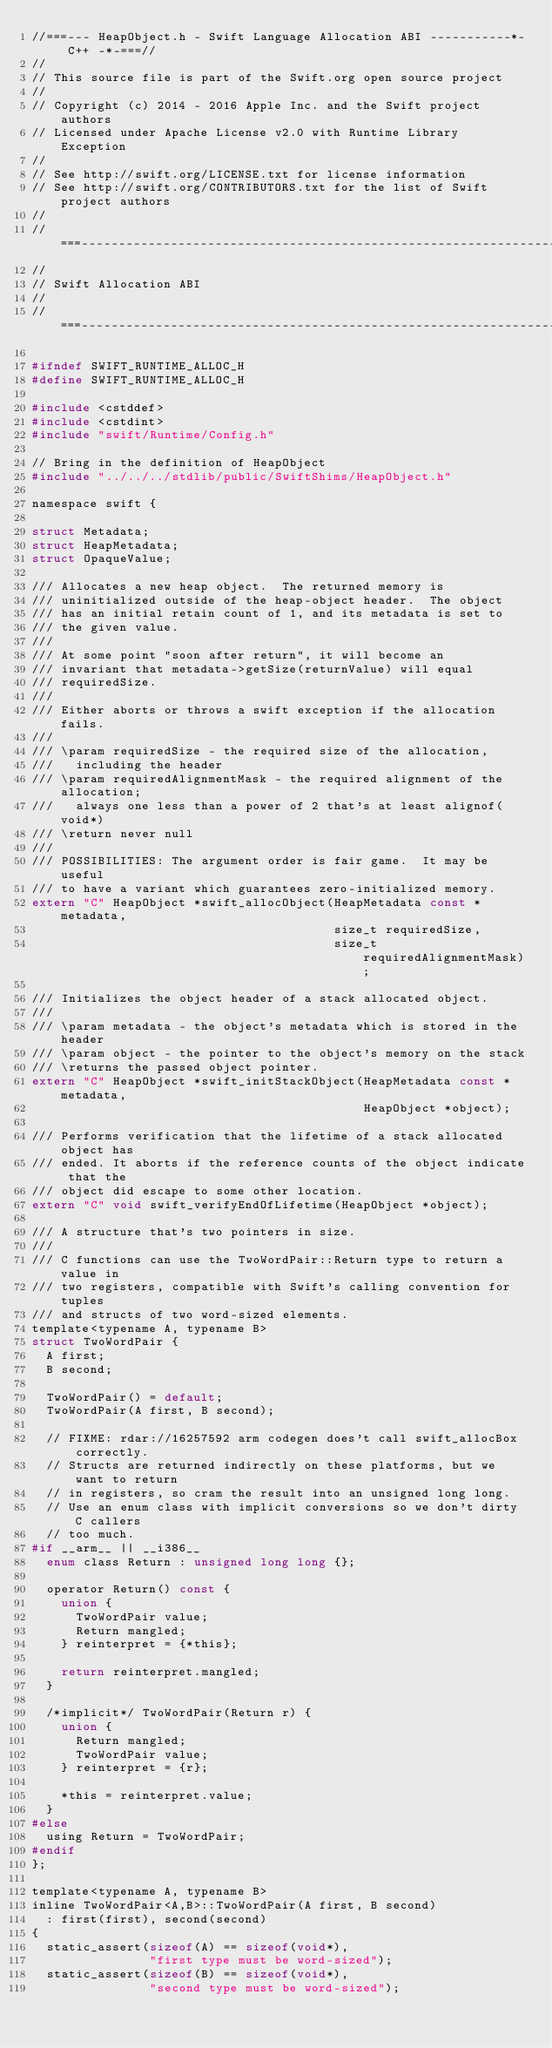<code> <loc_0><loc_0><loc_500><loc_500><_C_>//===--- HeapObject.h - Swift Language Allocation ABI -----------*- C++ -*-===//
//
// This source file is part of the Swift.org open source project
//
// Copyright (c) 2014 - 2016 Apple Inc. and the Swift project authors
// Licensed under Apache License v2.0 with Runtime Library Exception
//
// See http://swift.org/LICENSE.txt for license information
// See http://swift.org/CONTRIBUTORS.txt for the list of Swift project authors
//
//===----------------------------------------------------------------------===//
//
// Swift Allocation ABI
//
//===----------------------------------------------------------------------===//

#ifndef SWIFT_RUNTIME_ALLOC_H
#define SWIFT_RUNTIME_ALLOC_H

#include <cstddef>
#include <cstdint>
#include "swift/Runtime/Config.h"

// Bring in the definition of HeapObject 
#include "../../../stdlib/public/SwiftShims/HeapObject.h"

namespace swift {

struct Metadata;
struct HeapMetadata;
struct OpaqueValue;

/// Allocates a new heap object.  The returned memory is
/// uninitialized outside of the heap-object header.  The object
/// has an initial retain count of 1, and its metadata is set to
/// the given value.
///
/// At some point "soon after return", it will become an
/// invariant that metadata->getSize(returnValue) will equal
/// requiredSize.
///
/// Either aborts or throws a swift exception if the allocation fails.
///
/// \param requiredSize - the required size of the allocation,
///   including the header
/// \param requiredAlignmentMask - the required alignment of the allocation;
///   always one less than a power of 2 that's at least alignof(void*)
/// \return never null
///
/// POSSIBILITIES: The argument order is fair game.  It may be useful
/// to have a variant which guarantees zero-initialized memory.
extern "C" HeapObject *swift_allocObject(HeapMetadata const *metadata,
                                         size_t requiredSize,
                                         size_t requiredAlignmentMask);

/// Initializes the object header of a stack allocated object.
///
/// \param metadata - the object's metadata which is stored in the header
/// \param object - the pointer to the object's memory on the stack
/// \returns the passed object pointer.
extern "C" HeapObject *swift_initStackObject(HeapMetadata const *metadata,
                                             HeapObject *object);

/// Performs verification that the lifetime of a stack allocated object has
/// ended. It aborts if the reference counts of the object indicate that the
/// object did escape to some other location.
extern "C" void swift_verifyEndOfLifetime(HeapObject *object);

/// A structure that's two pointers in size.
///
/// C functions can use the TwoWordPair::Return type to return a value in
/// two registers, compatible with Swift's calling convention for tuples
/// and structs of two word-sized elements.
template<typename A, typename B>
struct TwoWordPair {
  A first;
  B second;
  
  TwoWordPair() = default;
  TwoWordPair(A first, B second);

  // FIXME: rdar://16257592 arm codegen does't call swift_allocBox correctly.
  // Structs are returned indirectly on these platforms, but we want to return
  // in registers, so cram the result into an unsigned long long.
  // Use an enum class with implicit conversions so we don't dirty C callers
  // too much.
#if __arm__ || __i386__
  enum class Return : unsigned long long {};
  
  operator Return() const {
    union {
      TwoWordPair value;
      Return mangled;
    } reinterpret = {*this};
    
    return reinterpret.mangled;
  }
  
  /*implicit*/ TwoWordPair(Return r) {
    union {
      Return mangled;
      TwoWordPair value;
    } reinterpret = {r};
    
    *this = reinterpret.value;
  }
#else
  using Return = TwoWordPair;
#endif
};
  
template<typename A, typename B>
inline TwoWordPair<A,B>::TwoWordPair(A first, B second)
  : first(first), second(second)
{
  static_assert(sizeof(A) == sizeof(void*),
                "first type must be word-sized");
  static_assert(sizeof(B) == sizeof(void*),
                "second type must be word-sized");</code> 